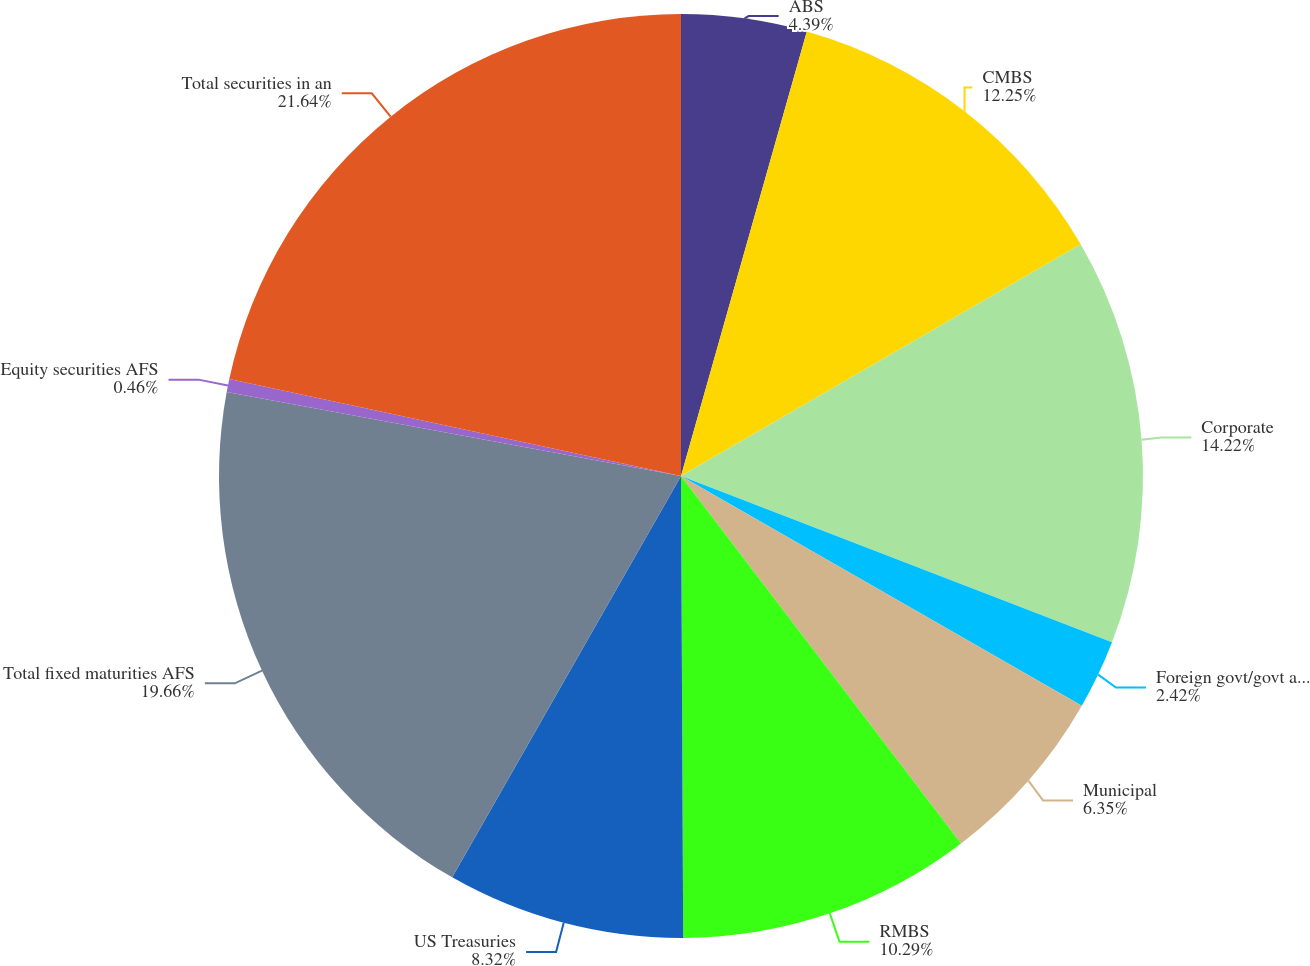<chart> <loc_0><loc_0><loc_500><loc_500><pie_chart><fcel>ABS<fcel>CMBS<fcel>Corporate<fcel>Foreign govt/govt agencies<fcel>Municipal<fcel>RMBS<fcel>US Treasuries<fcel>Total fixed maturities AFS<fcel>Equity securities AFS<fcel>Total securities in an<nl><fcel>4.39%<fcel>12.25%<fcel>14.22%<fcel>2.42%<fcel>6.35%<fcel>10.29%<fcel>8.32%<fcel>19.66%<fcel>0.46%<fcel>21.63%<nl></chart> 